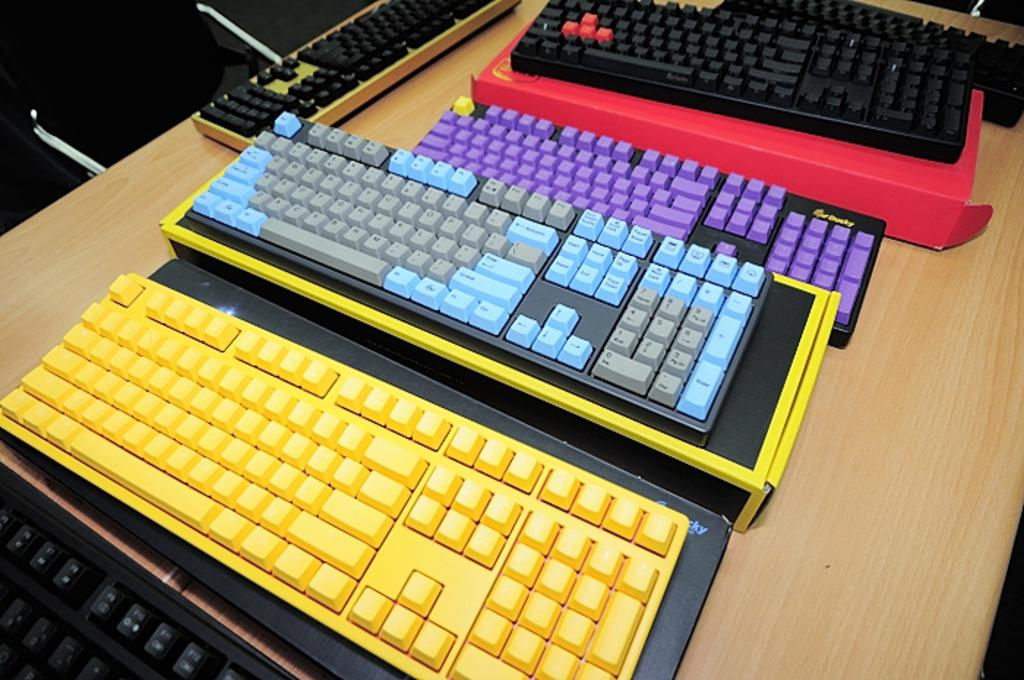What is the main object in the foreground of the image? There is a wooden table in the foreground of the image. What items are placed on the table? There are keyboards of different colors and a cardboard box on the table. Can you describe the chair in the image? There appears to be a black chair in the top left corner of the image. What type of thrill can be experienced by the kitten in the image? There is no kitten present in the image, so it is not possible to determine any thrill experienced. What time of day is depicted in the image? The provided facts do not mention the time of day, so it cannot be determined from the image. 